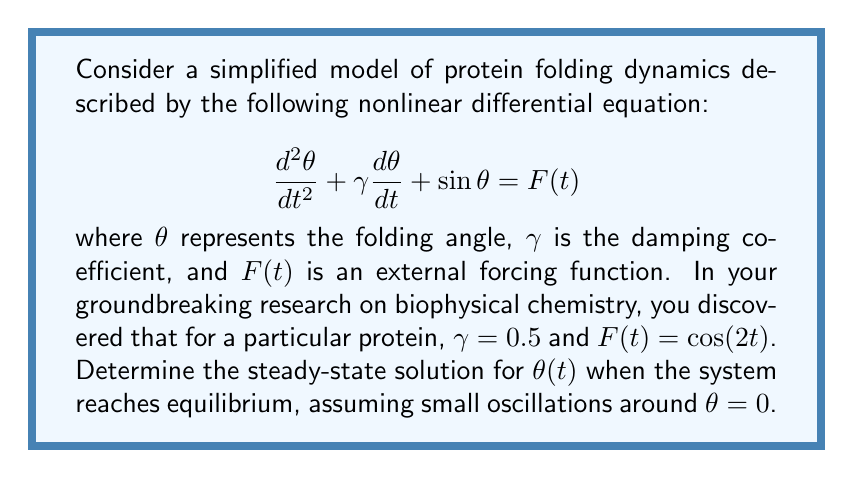Help me with this question. To solve this problem, we'll follow these steps:

1) For small oscillations around $\theta = 0$, we can approximate $\sin\theta \approx \theta$. This linearizes our equation:

   $$\frac{d^2\theta}{dt^2} + 0.5\frac{d\theta}{dt} + \theta = \cos(2t)$$

2) For the steady-state solution, we assume a solution of the form:

   $$\theta(t) = A\cos(2t) + B\sin(2t)$$

3) We need to find $A$ and $B$. Let's substitute this into our differential equation:

   $$[-4A\cos(2t) - 4B\sin(2t)] + 0.5[(-2A\sin(2t) + 2B\cos(2t))] + [A\cos(2t) + B\sin(2t)] = \cos(2t)$$

4) Grouping $\cos(2t)$ and $\sin(2t)$ terms:

   $$(-4A + B + A)\cos(2t) + (-4B - A + B)\sin(2t) = \cos(2t)$$

5) For this to be true for all $t$, the coefficients must match on both sides:

   $$-3A + B = 1$$
   $$-3B - A = 0$$

6) Solving this system of equations:
   From the second equation: $A = -3B$
   Substituting into the first: $-3(-3B) + B = 1$
   $9B + B = 1$
   $10B = 1$
   $B = 0.1$

   Then $A = -3B = -0.3$

7) Therefore, the steady-state solution is:

   $$\theta(t) = -0.3\cos(2t) + 0.1\sin(2t)$$
Answer: $\theta(t) = -0.3\cos(2t) + 0.1\sin(2t)$ 